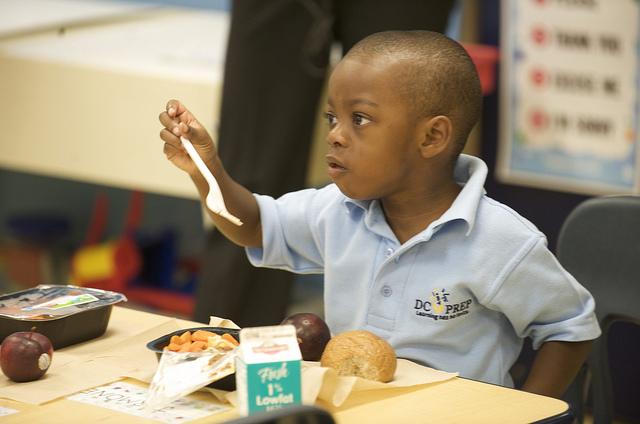Is he done eating?
Be succinct. No. What food is on the plate?
Quick response, please. Carrots. What is the boy holding?
Answer briefly. Fork. Is this food healthy?
Write a very short answer. Yes. What is the child eating?
Write a very short answer. Lunch. Is the child probably at school?
Quick response, please. Yes. Is the boy's hair curly or straight?
Concise answer only. Straight. Does the child look like they're enjoying their lunch?
Short answer required. Yes. What is the child wearing?
Give a very brief answer. Shirt. 